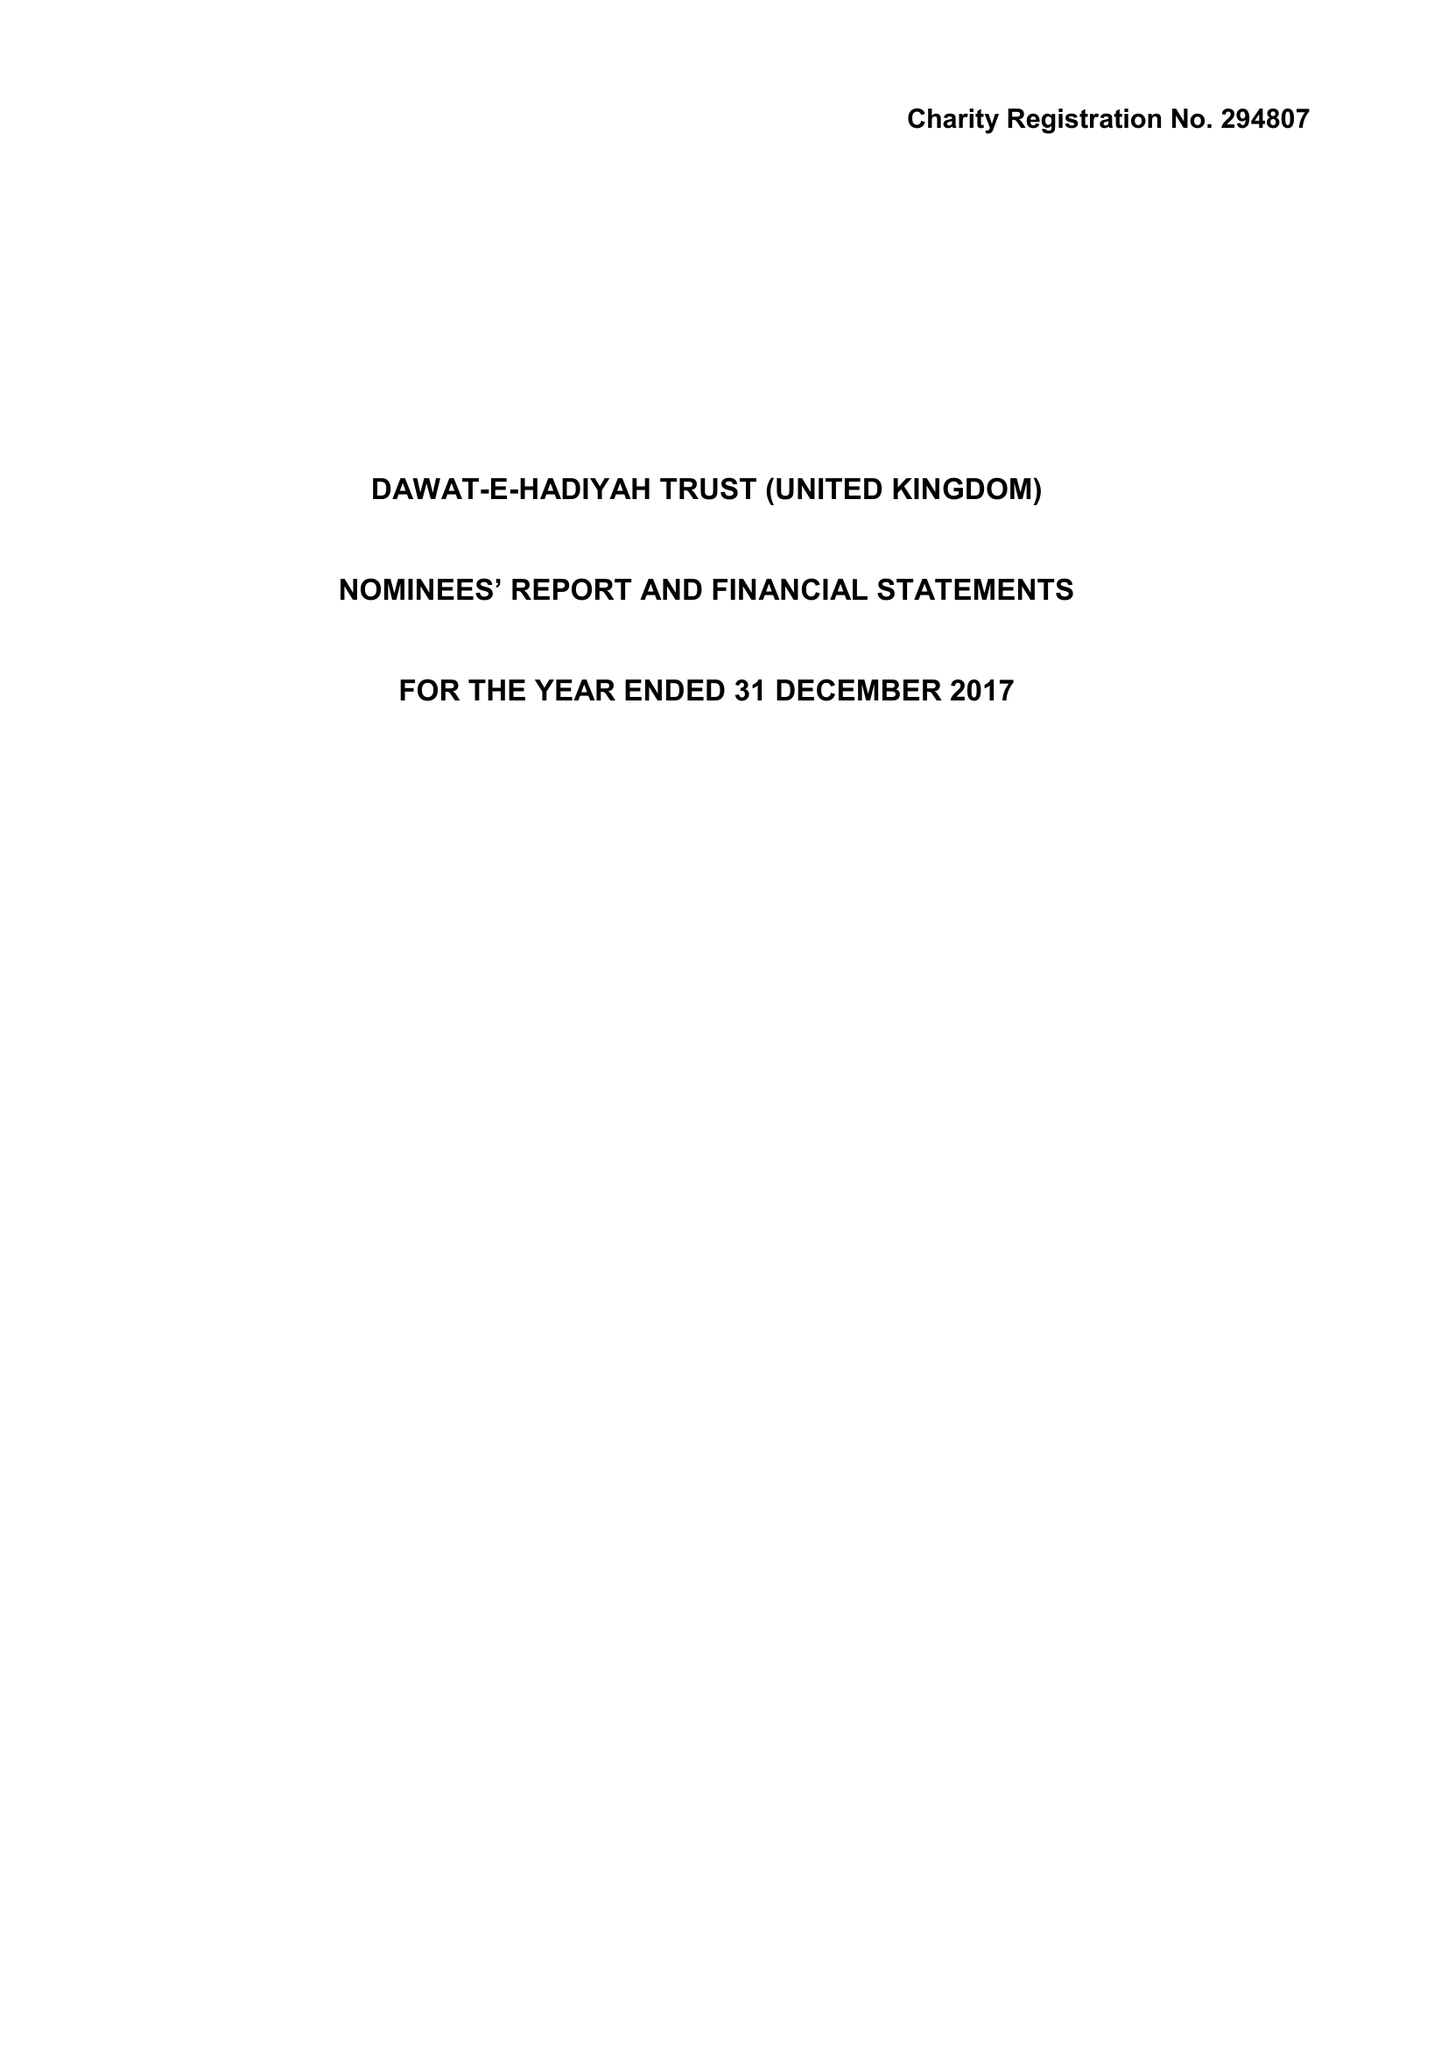What is the value for the address__street_line?
Answer the question using a single word or phrase. ROWDELL ROAD 